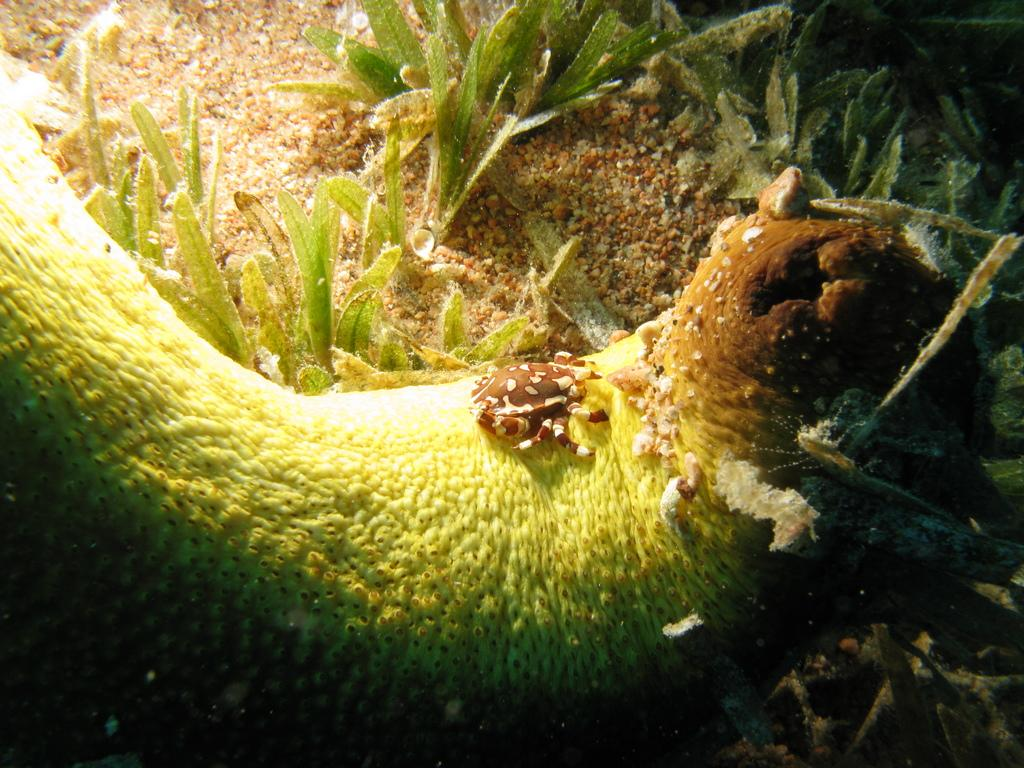What type of creatures can be seen in the image? There are underwater creatures in the image. What else is present in the image besides the creatures? There are plants and sand in the image. What type of boot is visible in the image? There is no boot present in the image; it features underwater creatures, plants, and sand. 